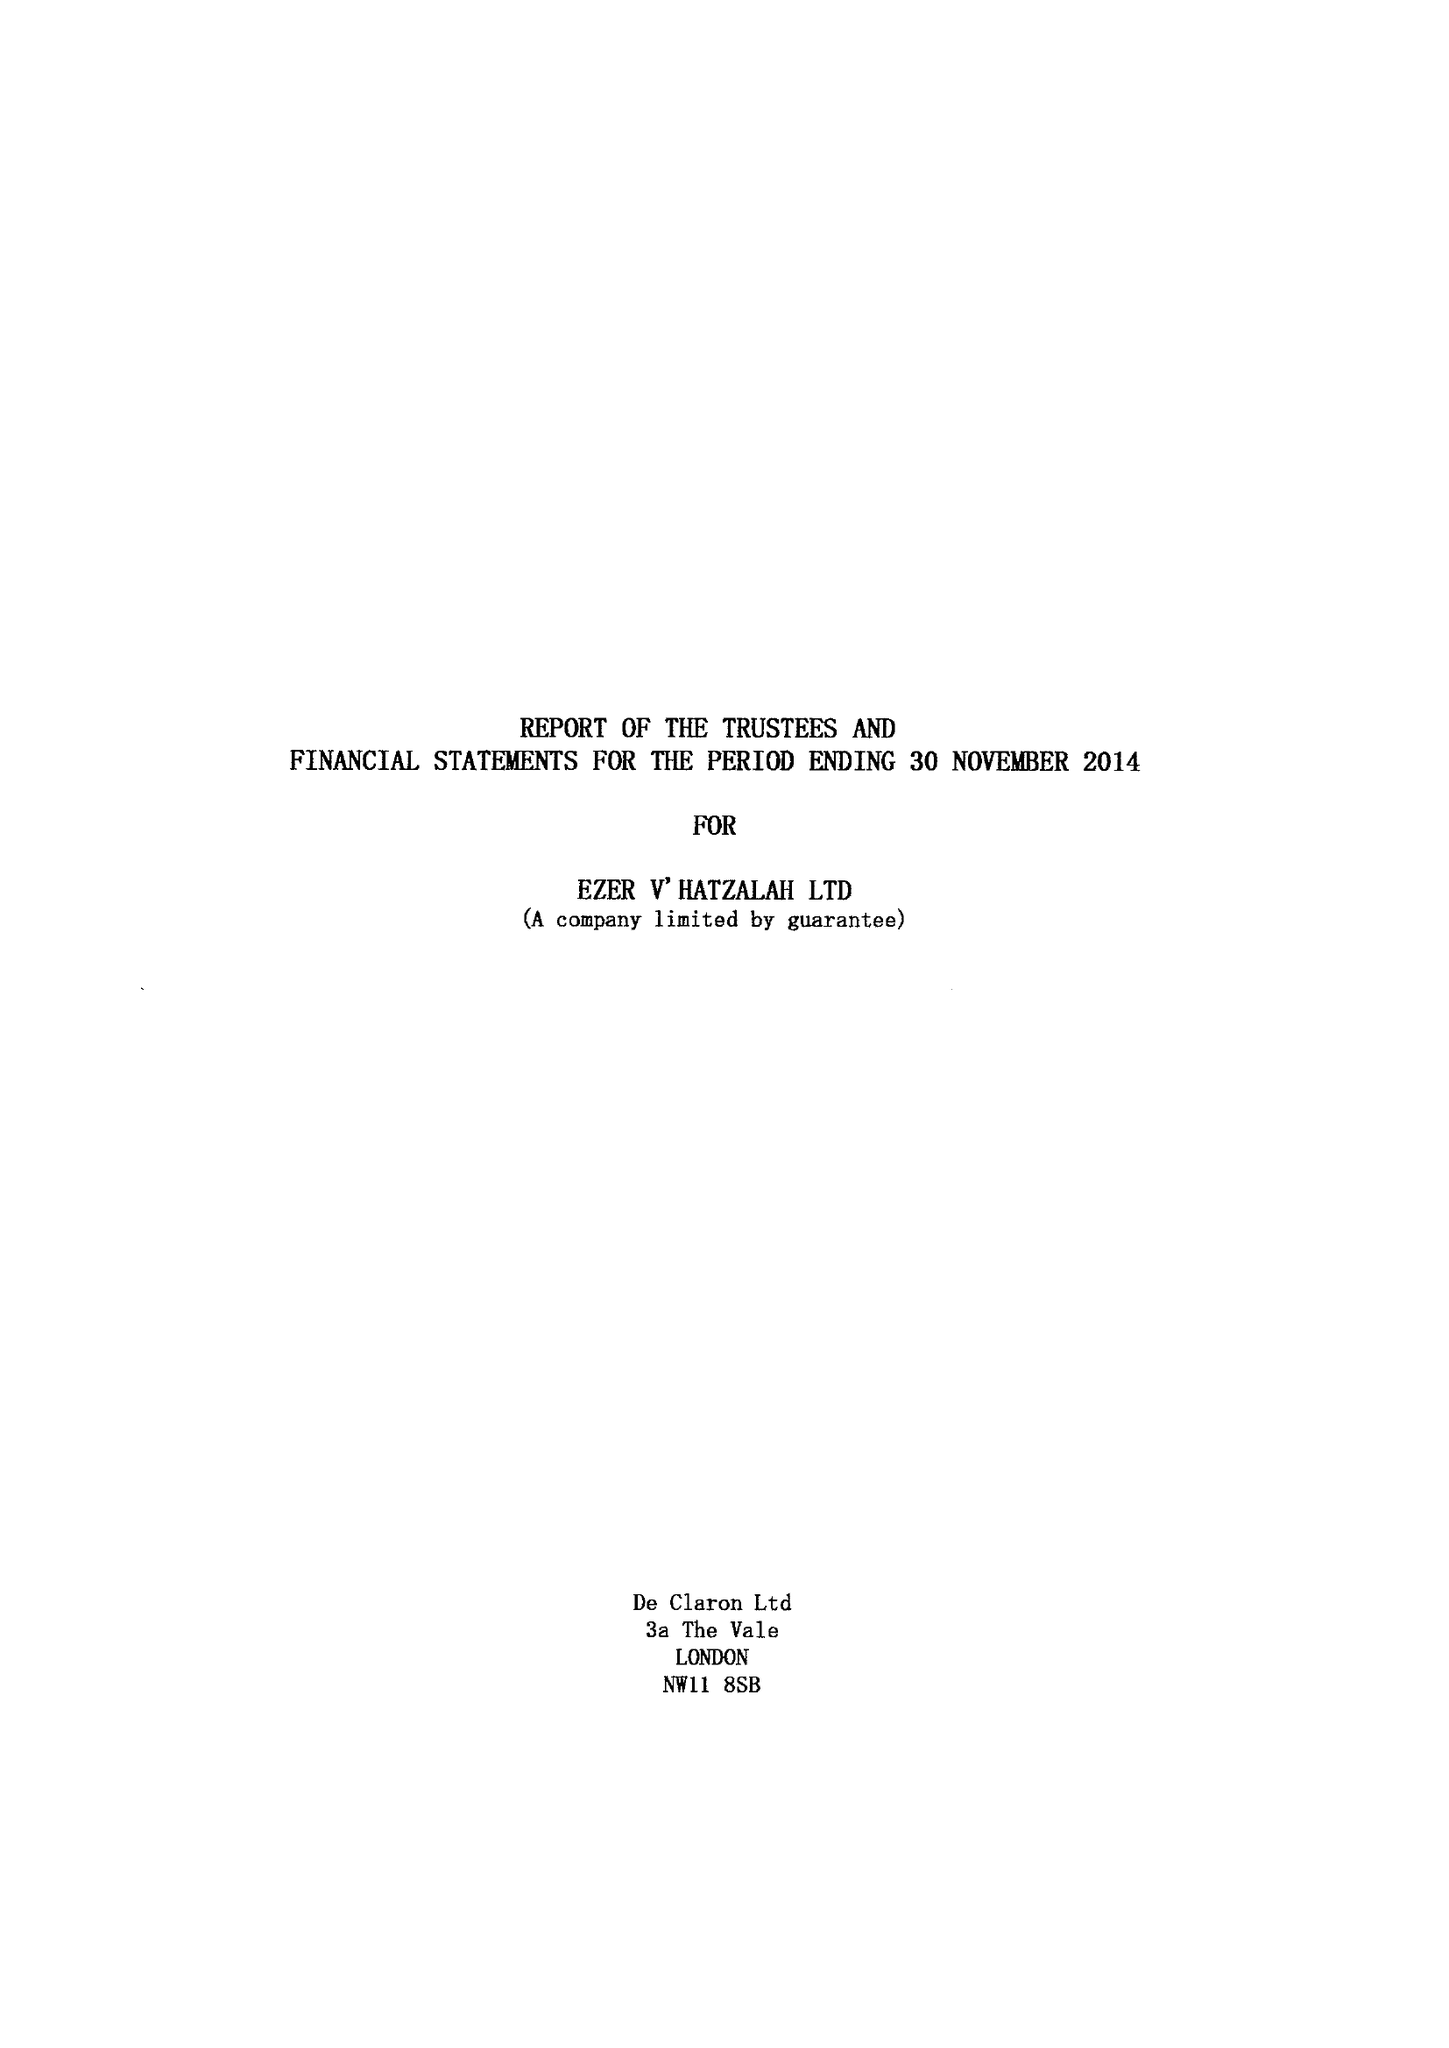What is the value for the address__post_town?
Answer the question using a single word or phrase. LONDON 